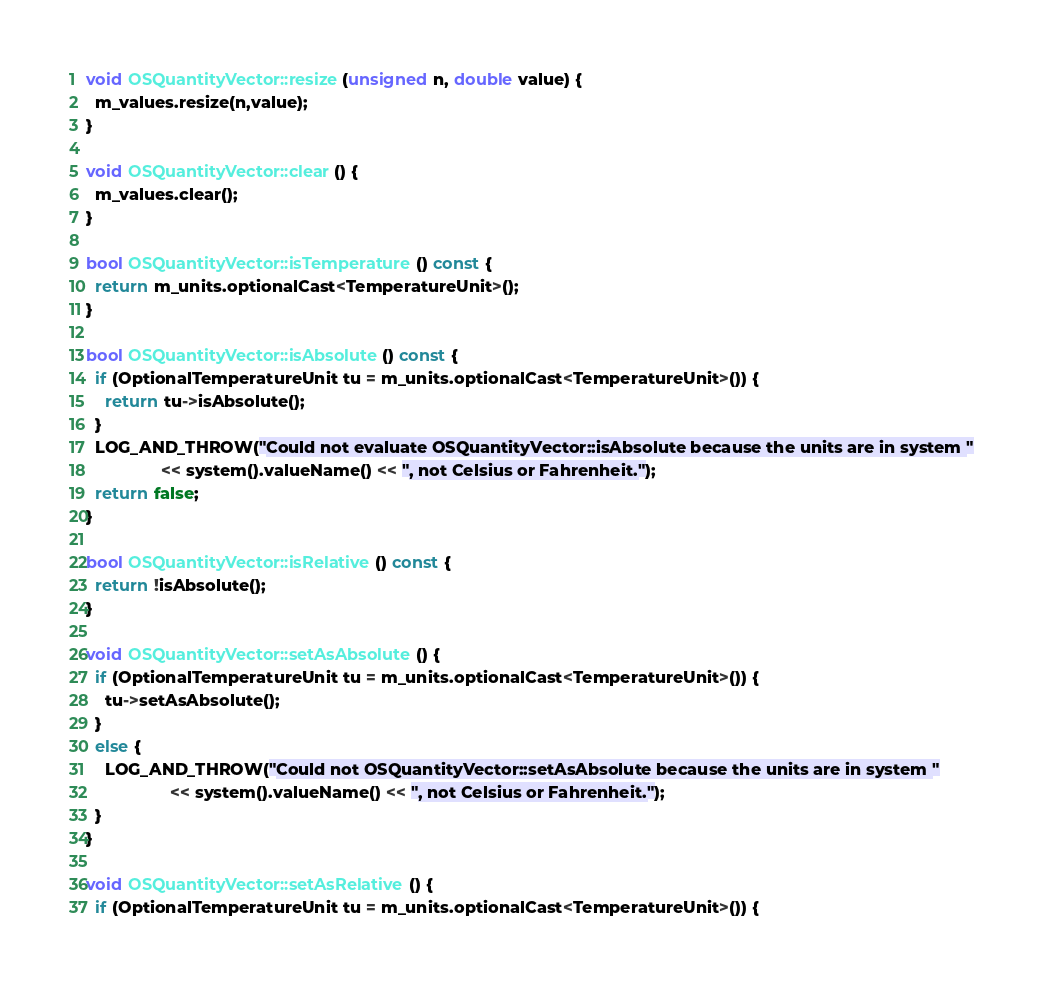<code> <loc_0><loc_0><loc_500><loc_500><_C++_>void OSQuantityVector::resize(unsigned n, double value) {
  m_values.resize(n,value);
}

void OSQuantityVector::clear() {
  m_values.clear();
}

bool OSQuantityVector::isTemperature() const {
  return m_units.optionalCast<TemperatureUnit>();
}

bool OSQuantityVector::isAbsolute() const {
  if (OptionalTemperatureUnit tu = m_units.optionalCast<TemperatureUnit>()) {
    return tu->isAbsolute();
  }
  LOG_AND_THROW("Could not evaluate OSQuantityVector::isAbsolute because the units are in system "
                << system().valueName() << ", not Celsius or Fahrenheit.");
  return false;
}

bool OSQuantityVector::isRelative() const {
  return !isAbsolute();
}

void OSQuantityVector::setAsAbsolute() {
  if (OptionalTemperatureUnit tu = m_units.optionalCast<TemperatureUnit>()) {
    tu->setAsAbsolute();
  }
  else {
    LOG_AND_THROW("Could not OSQuantityVector::setAsAbsolute because the units are in system "
                  << system().valueName() << ", not Celsius or Fahrenheit.");
  }
}

void OSQuantityVector::setAsRelative() {
  if (OptionalTemperatureUnit tu = m_units.optionalCast<TemperatureUnit>()) {</code> 